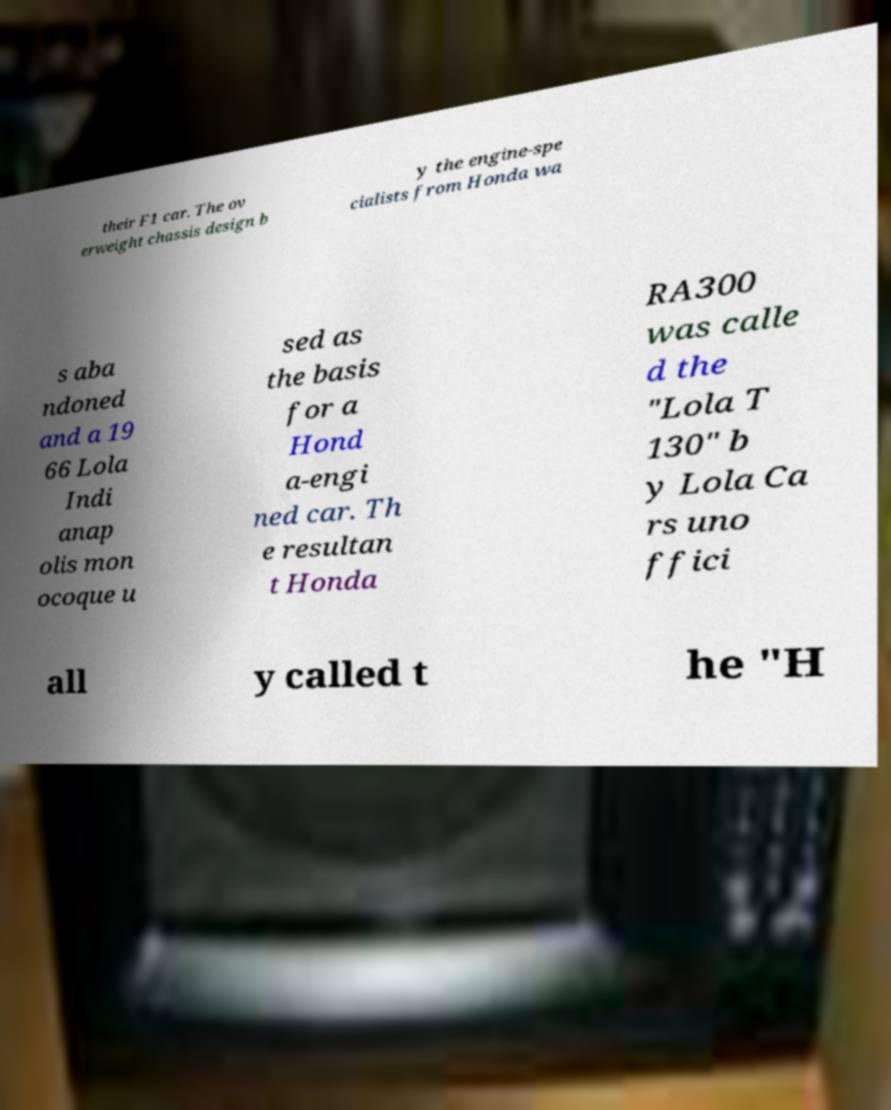Please identify and transcribe the text found in this image. their F1 car. The ov erweight chassis design b y the engine-spe cialists from Honda wa s aba ndoned and a 19 66 Lola Indi anap olis mon ocoque u sed as the basis for a Hond a-engi ned car. Th e resultan t Honda RA300 was calle d the "Lola T 130" b y Lola Ca rs uno ffici all y called t he "H 